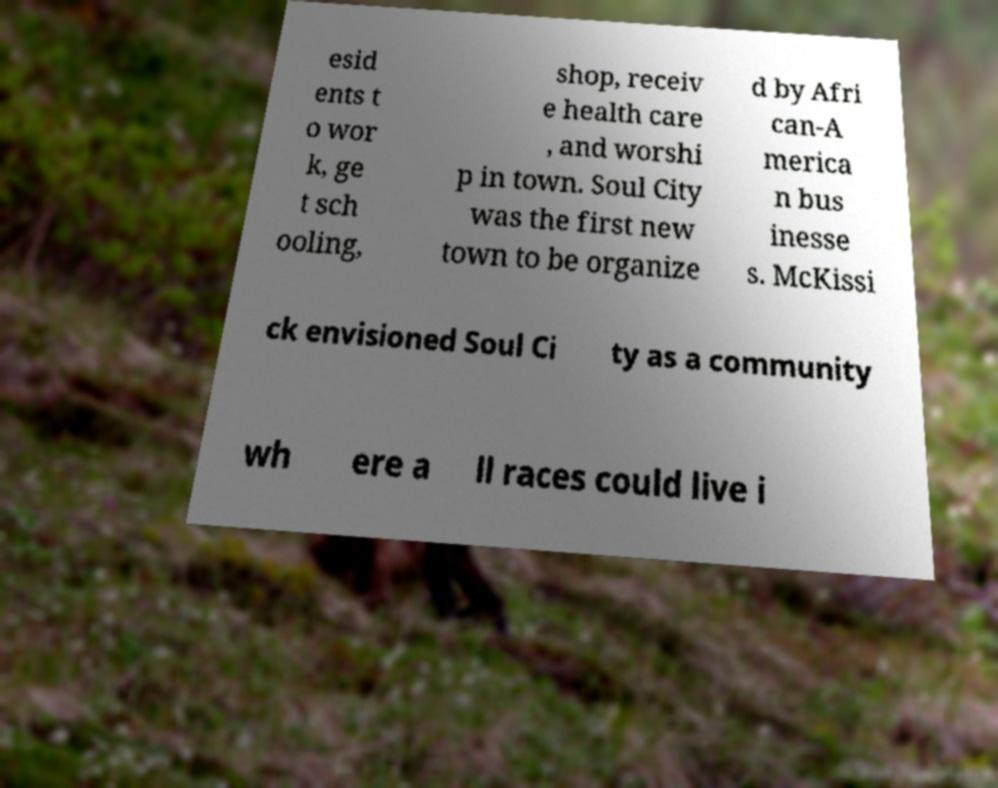Could you assist in decoding the text presented in this image and type it out clearly? esid ents t o wor k, ge t sch ooling, shop, receiv e health care , and worshi p in town. Soul City was the first new town to be organize d by Afri can-A merica n bus inesse s. McKissi ck envisioned Soul Ci ty as a community wh ere a ll races could live i 